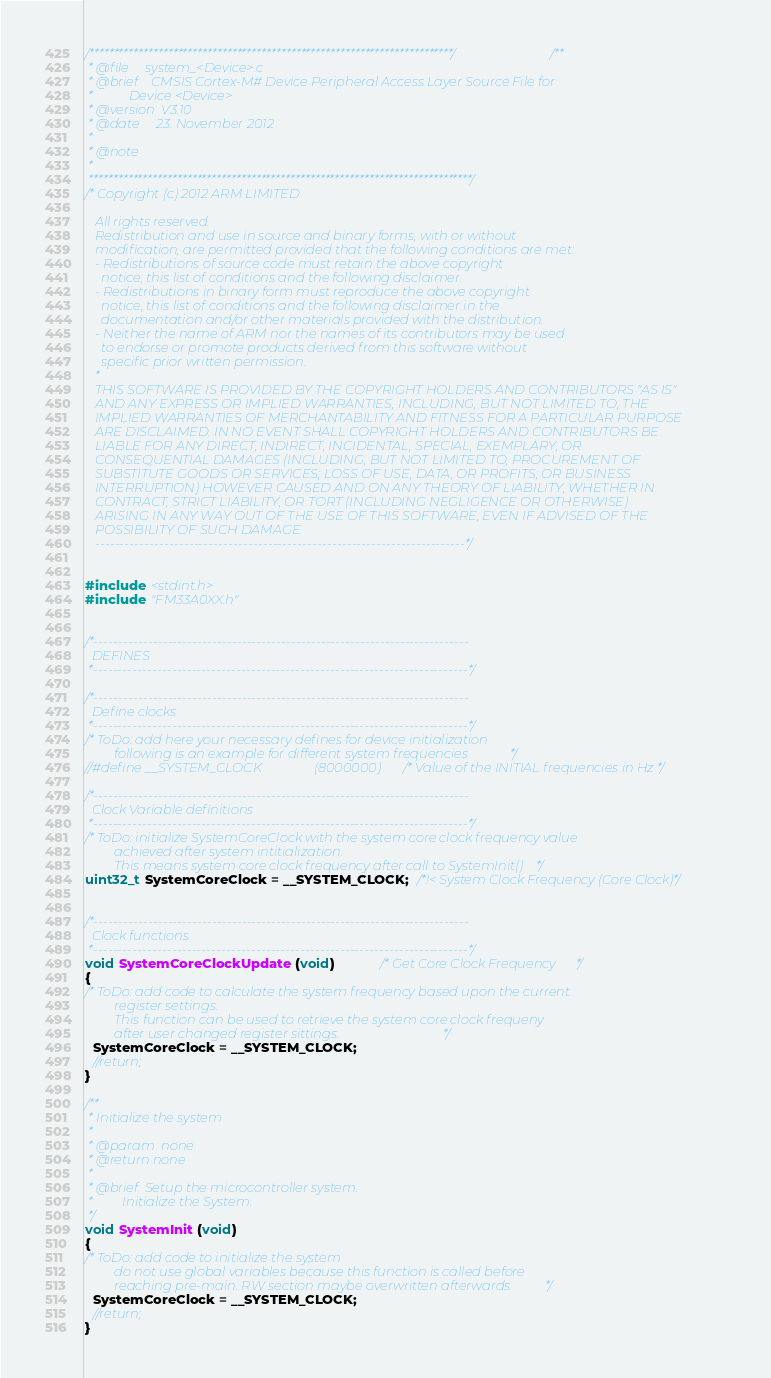Convert code to text. <code><loc_0><loc_0><loc_500><loc_500><_C_>/**************************************************************************//**
 * @file     system_<Device>.c
 * @brief    CMSIS Cortex-M# Device Peripheral Access Layer Source File for
 *           Device <Device>
 * @version  V3.10
 * @date     23. November 2012
 *
 * @note
 *
 ******************************************************************************/
/* Copyright (c) 2012 ARM LIMITED

   All rights reserved.
   Redistribution and use in source and binary forms, with or without
   modification, are permitted provided that the following conditions are met:
   - Redistributions of source code must retain the above copyright
     notice, this list of conditions and the following disclaimer.
   - Redistributions in binary form must reproduce the above copyright
     notice, this list of conditions and the following disclaimer in the
     documentation and/or other materials provided with the distribution.
   - Neither the name of ARM nor the names of its contributors may be used
     to endorse or promote products derived from this software without
     specific prior written permission.
   *
   THIS SOFTWARE IS PROVIDED BY THE COPYRIGHT HOLDERS AND CONTRIBUTORS "AS IS"
   AND ANY EXPRESS OR IMPLIED WARRANTIES, INCLUDING, BUT NOT LIMITED TO, THE
   IMPLIED WARRANTIES OF MERCHANTABILITY AND FITNESS FOR A PARTICULAR PURPOSE
   ARE DISCLAIMED. IN NO EVENT SHALL COPYRIGHT HOLDERS AND CONTRIBUTORS BE
   LIABLE FOR ANY DIRECT, INDIRECT, INCIDENTAL, SPECIAL, EXEMPLARY, OR
   CONSEQUENTIAL DAMAGES (INCLUDING, BUT NOT LIMITED TO, PROCUREMENT OF
   SUBSTITUTE GOODS OR SERVICES; LOSS OF USE, DATA, OR PROFITS; OR BUSINESS
   INTERRUPTION) HOWEVER CAUSED AND ON ANY THEORY OF LIABILITY, WHETHER IN
   CONTRACT, STRICT LIABILITY, OR TORT (INCLUDING NEGLIGENCE OR OTHERWISE)
   ARISING IN ANY WAY OUT OF THE USE OF THIS SOFTWARE, EVEN IF ADVISED OF THE
   POSSIBILITY OF SUCH DAMAGE.
   ---------------------------------------------------------------------------*/


#include <stdint.h>
#include "FM33A0XX.h"


/*----------------------------------------------------------------------------
  DEFINES
 *----------------------------------------------------------------------------*/

/*----------------------------------------------------------------------------
  Define clocks
 *----------------------------------------------------------------------------*/
/* ToDo: add here your necessary defines for device initialization
         following is an example for different system frequencies             */
//#define __SYSTEM_CLOCK    			(8000000)		/* Value of the INITIAL frequencies in Hz */

/*----------------------------------------------------------------------------
  Clock Variable definitions
 *----------------------------------------------------------------------------*/
/* ToDo: initialize SystemCoreClock with the system core clock frequency value
         achieved after system intitialization.
         This means system core clock frequency after call to SystemInit()    */
uint32_t SystemCoreClock = __SYSTEM_CLOCK;  /*!< System Clock Frequency (Core Clock)*/


/*----------------------------------------------------------------------------
  Clock functions
 *----------------------------------------------------------------------------*/
void SystemCoreClockUpdate (void)            /* Get Core Clock Frequency      */
{
/* ToDo: add code to calculate the system frequency based upon the current
         register settings.
         This function can be used to retrieve the system core clock frequeny
         after user changed register sittings.                                */
  SystemCoreClock = __SYSTEM_CLOCK;
  //return;
}

/**
 * Initialize the system
 *
 * @param  none
 * @return none
 *
 * @brief  Setup the microcontroller system.
 *         Initialize the System.
 */
void SystemInit (void)
{
/* ToDo: add code to initialize the system
         do not use global variables because this function is called before
         reaching pre-main. RW section maybe overwritten afterwards.          */
  SystemCoreClock = __SYSTEM_CLOCK;
  //return;
}
</code> 